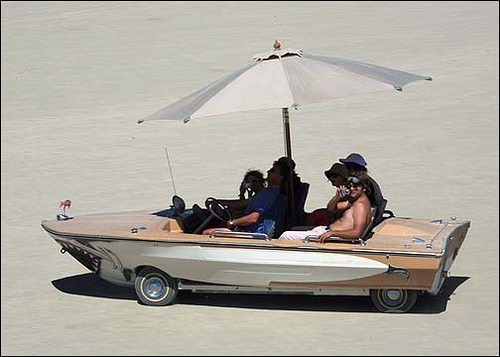<image>
Can you confirm if the umbrella is in the boat? Yes. The umbrella is contained within or inside the boat, showing a containment relationship. Where is the umbrella in relation to the boat? Is it on the boat? Yes. Looking at the image, I can see the umbrella is positioned on top of the boat, with the boat providing support. 